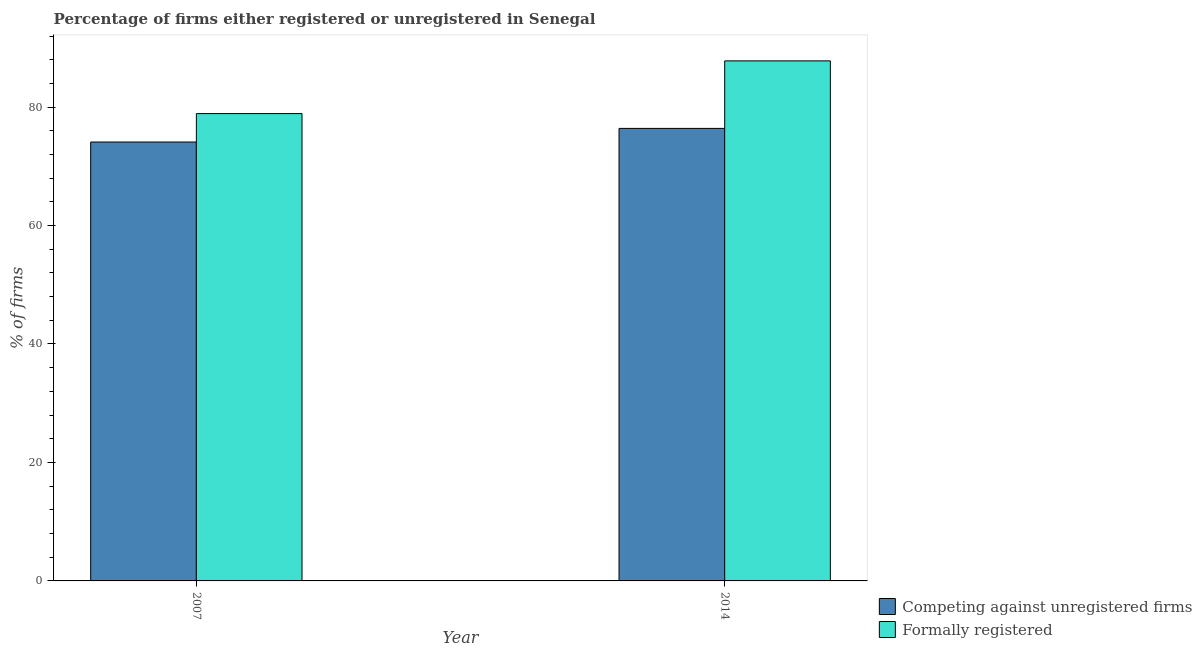How many different coloured bars are there?
Ensure brevity in your answer.  2. How many bars are there on the 2nd tick from the right?
Offer a terse response. 2. What is the label of the 2nd group of bars from the left?
Offer a very short reply. 2014. What is the percentage of formally registered firms in 2014?
Keep it short and to the point. 87.8. Across all years, what is the maximum percentage of formally registered firms?
Offer a terse response. 87.8. Across all years, what is the minimum percentage of registered firms?
Make the answer very short. 74.1. In which year was the percentage of registered firms maximum?
Give a very brief answer. 2014. In which year was the percentage of registered firms minimum?
Offer a terse response. 2007. What is the total percentage of formally registered firms in the graph?
Keep it short and to the point. 166.7. What is the difference between the percentage of formally registered firms in 2007 and that in 2014?
Provide a short and direct response. -8.9. What is the difference between the percentage of registered firms in 2014 and the percentage of formally registered firms in 2007?
Offer a terse response. 2.3. What is the average percentage of formally registered firms per year?
Keep it short and to the point. 83.35. In the year 2014, what is the difference between the percentage of formally registered firms and percentage of registered firms?
Provide a short and direct response. 0. What is the ratio of the percentage of registered firms in 2007 to that in 2014?
Your response must be concise. 0.97. Is the percentage of registered firms in 2007 less than that in 2014?
Offer a terse response. Yes. In how many years, is the percentage of formally registered firms greater than the average percentage of formally registered firms taken over all years?
Offer a very short reply. 1. What does the 1st bar from the left in 2007 represents?
Keep it short and to the point. Competing against unregistered firms. What does the 1st bar from the right in 2014 represents?
Provide a succinct answer. Formally registered. Are all the bars in the graph horizontal?
Ensure brevity in your answer.  No. How many years are there in the graph?
Your response must be concise. 2. Does the graph contain any zero values?
Your answer should be compact. No. Where does the legend appear in the graph?
Ensure brevity in your answer.  Bottom right. How are the legend labels stacked?
Make the answer very short. Vertical. What is the title of the graph?
Ensure brevity in your answer.  Percentage of firms either registered or unregistered in Senegal. Does "Food" appear as one of the legend labels in the graph?
Keep it short and to the point. No. What is the label or title of the Y-axis?
Ensure brevity in your answer.  % of firms. What is the % of firms of Competing against unregistered firms in 2007?
Make the answer very short. 74.1. What is the % of firms in Formally registered in 2007?
Your response must be concise. 78.9. What is the % of firms of Competing against unregistered firms in 2014?
Provide a succinct answer. 76.4. What is the % of firms in Formally registered in 2014?
Your response must be concise. 87.8. Across all years, what is the maximum % of firms in Competing against unregistered firms?
Ensure brevity in your answer.  76.4. Across all years, what is the maximum % of firms of Formally registered?
Ensure brevity in your answer.  87.8. Across all years, what is the minimum % of firms in Competing against unregistered firms?
Make the answer very short. 74.1. Across all years, what is the minimum % of firms of Formally registered?
Give a very brief answer. 78.9. What is the total % of firms of Competing against unregistered firms in the graph?
Your answer should be compact. 150.5. What is the total % of firms in Formally registered in the graph?
Provide a short and direct response. 166.7. What is the difference between the % of firms in Competing against unregistered firms in 2007 and that in 2014?
Your answer should be compact. -2.3. What is the difference between the % of firms of Formally registered in 2007 and that in 2014?
Provide a succinct answer. -8.9. What is the difference between the % of firms of Competing against unregistered firms in 2007 and the % of firms of Formally registered in 2014?
Keep it short and to the point. -13.7. What is the average % of firms of Competing against unregistered firms per year?
Offer a terse response. 75.25. What is the average % of firms of Formally registered per year?
Offer a very short reply. 83.35. In the year 2007, what is the difference between the % of firms in Competing against unregistered firms and % of firms in Formally registered?
Your answer should be compact. -4.8. What is the ratio of the % of firms of Competing against unregistered firms in 2007 to that in 2014?
Keep it short and to the point. 0.97. What is the ratio of the % of firms of Formally registered in 2007 to that in 2014?
Offer a terse response. 0.9. 